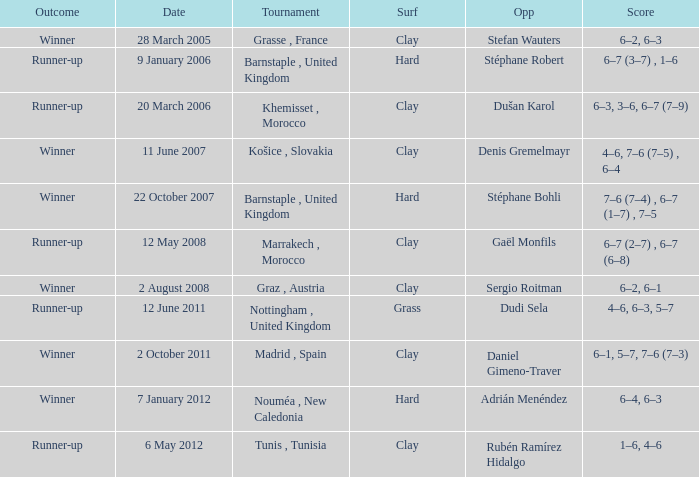What is the score on 2 October 2011? 6–1, 5–7, 7–6 (7–3). 